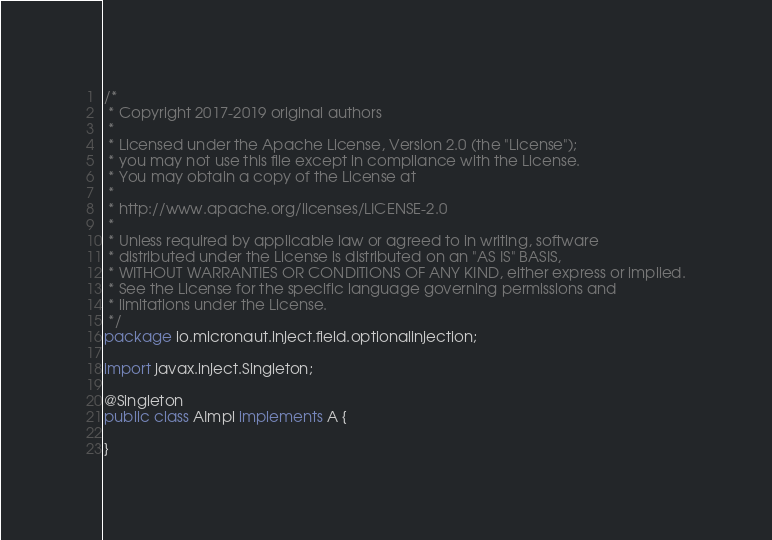<code> <loc_0><loc_0><loc_500><loc_500><_Java_>/*
 * Copyright 2017-2019 original authors
 *
 * Licensed under the Apache License, Version 2.0 (the "License");
 * you may not use this file except in compliance with the License.
 * You may obtain a copy of the License at
 *
 * http://www.apache.org/licenses/LICENSE-2.0
 *
 * Unless required by applicable law or agreed to in writing, software
 * distributed under the License is distributed on an "AS IS" BASIS,
 * WITHOUT WARRANTIES OR CONDITIONS OF ANY KIND, either express or implied.
 * See the License for the specific language governing permissions and
 * limitations under the License.
 */
package io.micronaut.inject.field.optionalinjection;

import javax.inject.Singleton;

@Singleton
public class AImpl implements A {

}
</code> 